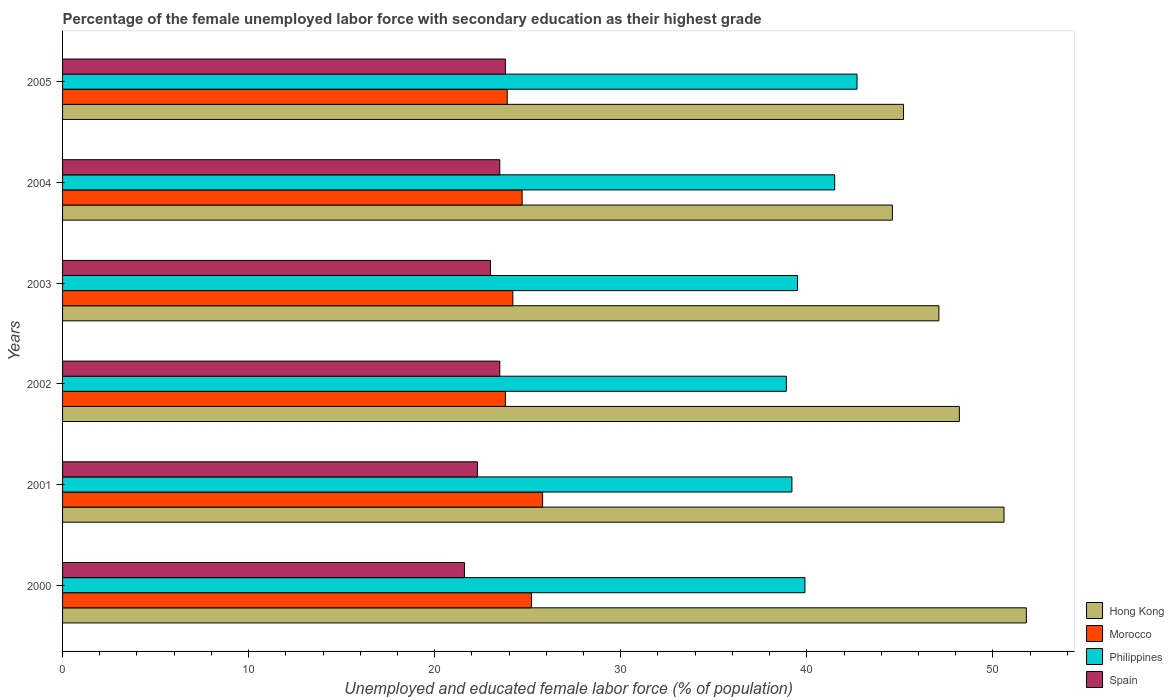How many bars are there on the 5th tick from the top?
Your response must be concise. 4. How many bars are there on the 4th tick from the bottom?
Keep it short and to the point. 4. In how many cases, is the number of bars for a given year not equal to the number of legend labels?
Provide a short and direct response. 0. What is the percentage of the unemployed female labor force with secondary education in Hong Kong in 2000?
Your answer should be compact. 51.8. Across all years, what is the maximum percentage of the unemployed female labor force with secondary education in Hong Kong?
Offer a very short reply. 51.8. Across all years, what is the minimum percentage of the unemployed female labor force with secondary education in Hong Kong?
Provide a short and direct response. 44.6. In which year was the percentage of the unemployed female labor force with secondary education in Spain maximum?
Provide a succinct answer. 2005. What is the total percentage of the unemployed female labor force with secondary education in Spain in the graph?
Offer a terse response. 137.7. What is the difference between the percentage of the unemployed female labor force with secondary education in Hong Kong in 2003 and that in 2005?
Offer a very short reply. 1.9. What is the difference between the percentage of the unemployed female labor force with secondary education in Philippines in 2000 and the percentage of the unemployed female labor force with secondary education in Morocco in 2003?
Make the answer very short. 15.7. What is the average percentage of the unemployed female labor force with secondary education in Morocco per year?
Ensure brevity in your answer.  24.6. In the year 2000, what is the difference between the percentage of the unemployed female labor force with secondary education in Morocco and percentage of the unemployed female labor force with secondary education in Hong Kong?
Your answer should be very brief. -26.6. In how many years, is the percentage of the unemployed female labor force with secondary education in Philippines greater than 20 %?
Your response must be concise. 6. What is the ratio of the percentage of the unemployed female labor force with secondary education in Hong Kong in 2003 to that in 2005?
Your answer should be very brief. 1.04. Is the percentage of the unemployed female labor force with secondary education in Morocco in 2001 less than that in 2005?
Make the answer very short. No. Is the difference between the percentage of the unemployed female labor force with secondary education in Morocco in 2004 and 2005 greater than the difference between the percentage of the unemployed female labor force with secondary education in Hong Kong in 2004 and 2005?
Offer a very short reply. Yes. What is the difference between the highest and the second highest percentage of the unemployed female labor force with secondary education in Philippines?
Your response must be concise. 1.2. What is the difference between the highest and the lowest percentage of the unemployed female labor force with secondary education in Spain?
Your answer should be compact. 2.2. In how many years, is the percentage of the unemployed female labor force with secondary education in Hong Kong greater than the average percentage of the unemployed female labor force with secondary education in Hong Kong taken over all years?
Keep it short and to the point. 3. Is the sum of the percentage of the unemployed female labor force with secondary education in Hong Kong in 2002 and 2004 greater than the maximum percentage of the unemployed female labor force with secondary education in Philippines across all years?
Your answer should be compact. Yes. What does the 3rd bar from the bottom in 2003 represents?
Keep it short and to the point. Philippines. Is it the case that in every year, the sum of the percentage of the unemployed female labor force with secondary education in Morocco and percentage of the unemployed female labor force with secondary education in Philippines is greater than the percentage of the unemployed female labor force with secondary education in Hong Kong?
Provide a succinct answer. Yes. How many bars are there?
Provide a short and direct response. 24. What is the difference between two consecutive major ticks on the X-axis?
Make the answer very short. 10. Does the graph contain grids?
Provide a succinct answer. No. What is the title of the graph?
Provide a succinct answer. Percentage of the female unemployed labor force with secondary education as their highest grade. Does "Iceland" appear as one of the legend labels in the graph?
Your response must be concise. No. What is the label or title of the X-axis?
Keep it short and to the point. Unemployed and educated female labor force (% of population). What is the Unemployed and educated female labor force (% of population) in Hong Kong in 2000?
Make the answer very short. 51.8. What is the Unemployed and educated female labor force (% of population) of Morocco in 2000?
Your answer should be very brief. 25.2. What is the Unemployed and educated female labor force (% of population) of Philippines in 2000?
Keep it short and to the point. 39.9. What is the Unemployed and educated female labor force (% of population) of Spain in 2000?
Offer a terse response. 21.6. What is the Unemployed and educated female labor force (% of population) in Hong Kong in 2001?
Make the answer very short. 50.6. What is the Unemployed and educated female labor force (% of population) of Morocco in 2001?
Your answer should be compact. 25.8. What is the Unemployed and educated female labor force (% of population) in Philippines in 2001?
Give a very brief answer. 39.2. What is the Unemployed and educated female labor force (% of population) of Spain in 2001?
Your answer should be compact. 22.3. What is the Unemployed and educated female labor force (% of population) of Hong Kong in 2002?
Provide a succinct answer. 48.2. What is the Unemployed and educated female labor force (% of population) in Morocco in 2002?
Make the answer very short. 23.8. What is the Unemployed and educated female labor force (% of population) in Philippines in 2002?
Ensure brevity in your answer.  38.9. What is the Unemployed and educated female labor force (% of population) of Hong Kong in 2003?
Ensure brevity in your answer.  47.1. What is the Unemployed and educated female labor force (% of population) in Morocco in 2003?
Ensure brevity in your answer.  24.2. What is the Unemployed and educated female labor force (% of population) in Philippines in 2003?
Keep it short and to the point. 39.5. What is the Unemployed and educated female labor force (% of population) in Hong Kong in 2004?
Provide a short and direct response. 44.6. What is the Unemployed and educated female labor force (% of population) in Morocco in 2004?
Provide a succinct answer. 24.7. What is the Unemployed and educated female labor force (% of population) of Philippines in 2004?
Keep it short and to the point. 41.5. What is the Unemployed and educated female labor force (% of population) of Hong Kong in 2005?
Give a very brief answer. 45.2. What is the Unemployed and educated female labor force (% of population) in Morocco in 2005?
Give a very brief answer. 23.9. What is the Unemployed and educated female labor force (% of population) of Philippines in 2005?
Make the answer very short. 42.7. What is the Unemployed and educated female labor force (% of population) of Spain in 2005?
Make the answer very short. 23.8. Across all years, what is the maximum Unemployed and educated female labor force (% of population) of Hong Kong?
Your response must be concise. 51.8. Across all years, what is the maximum Unemployed and educated female labor force (% of population) of Morocco?
Keep it short and to the point. 25.8. Across all years, what is the maximum Unemployed and educated female labor force (% of population) in Philippines?
Offer a very short reply. 42.7. Across all years, what is the maximum Unemployed and educated female labor force (% of population) of Spain?
Offer a very short reply. 23.8. Across all years, what is the minimum Unemployed and educated female labor force (% of population) of Hong Kong?
Make the answer very short. 44.6. Across all years, what is the minimum Unemployed and educated female labor force (% of population) of Morocco?
Provide a succinct answer. 23.8. Across all years, what is the minimum Unemployed and educated female labor force (% of population) of Philippines?
Provide a succinct answer. 38.9. Across all years, what is the minimum Unemployed and educated female labor force (% of population) in Spain?
Provide a short and direct response. 21.6. What is the total Unemployed and educated female labor force (% of population) in Hong Kong in the graph?
Your response must be concise. 287.5. What is the total Unemployed and educated female labor force (% of population) of Morocco in the graph?
Make the answer very short. 147.6. What is the total Unemployed and educated female labor force (% of population) of Philippines in the graph?
Provide a short and direct response. 241.7. What is the total Unemployed and educated female labor force (% of population) in Spain in the graph?
Keep it short and to the point. 137.7. What is the difference between the Unemployed and educated female labor force (% of population) in Hong Kong in 2000 and that in 2001?
Ensure brevity in your answer.  1.2. What is the difference between the Unemployed and educated female labor force (% of population) of Philippines in 2000 and that in 2001?
Give a very brief answer. 0.7. What is the difference between the Unemployed and educated female labor force (% of population) in Spain in 2000 and that in 2001?
Your response must be concise. -0.7. What is the difference between the Unemployed and educated female labor force (% of population) in Hong Kong in 2000 and that in 2002?
Your answer should be compact. 3.6. What is the difference between the Unemployed and educated female labor force (% of population) in Morocco in 2000 and that in 2002?
Make the answer very short. 1.4. What is the difference between the Unemployed and educated female labor force (% of population) in Philippines in 2000 and that in 2002?
Offer a very short reply. 1. What is the difference between the Unemployed and educated female labor force (% of population) in Morocco in 2000 and that in 2003?
Make the answer very short. 1. What is the difference between the Unemployed and educated female labor force (% of population) in Philippines in 2000 and that in 2003?
Keep it short and to the point. 0.4. What is the difference between the Unemployed and educated female labor force (% of population) of Spain in 2000 and that in 2003?
Your answer should be very brief. -1.4. What is the difference between the Unemployed and educated female labor force (% of population) of Spain in 2000 and that in 2004?
Your response must be concise. -1.9. What is the difference between the Unemployed and educated female labor force (% of population) in Spain in 2001 and that in 2002?
Keep it short and to the point. -1.2. What is the difference between the Unemployed and educated female labor force (% of population) of Hong Kong in 2001 and that in 2003?
Make the answer very short. 3.5. What is the difference between the Unemployed and educated female labor force (% of population) in Morocco in 2001 and that in 2003?
Make the answer very short. 1.6. What is the difference between the Unemployed and educated female labor force (% of population) in Spain in 2001 and that in 2003?
Make the answer very short. -0.7. What is the difference between the Unemployed and educated female labor force (% of population) in Hong Kong in 2001 and that in 2004?
Your answer should be compact. 6. What is the difference between the Unemployed and educated female labor force (% of population) of Morocco in 2001 and that in 2004?
Provide a short and direct response. 1.1. What is the difference between the Unemployed and educated female labor force (% of population) of Spain in 2001 and that in 2004?
Your answer should be compact. -1.2. What is the difference between the Unemployed and educated female labor force (% of population) in Hong Kong in 2001 and that in 2005?
Make the answer very short. 5.4. What is the difference between the Unemployed and educated female labor force (% of population) of Morocco in 2001 and that in 2005?
Ensure brevity in your answer.  1.9. What is the difference between the Unemployed and educated female labor force (% of population) in Philippines in 2001 and that in 2005?
Provide a short and direct response. -3.5. What is the difference between the Unemployed and educated female labor force (% of population) of Spain in 2001 and that in 2005?
Offer a very short reply. -1.5. What is the difference between the Unemployed and educated female labor force (% of population) in Morocco in 2002 and that in 2004?
Your response must be concise. -0.9. What is the difference between the Unemployed and educated female labor force (% of population) in Spain in 2002 and that in 2004?
Your response must be concise. 0. What is the difference between the Unemployed and educated female labor force (% of population) of Spain in 2002 and that in 2005?
Offer a terse response. -0.3. What is the difference between the Unemployed and educated female labor force (% of population) of Hong Kong in 2003 and that in 2004?
Give a very brief answer. 2.5. What is the difference between the Unemployed and educated female labor force (% of population) of Morocco in 2003 and that in 2004?
Offer a very short reply. -0.5. What is the difference between the Unemployed and educated female labor force (% of population) in Spain in 2003 and that in 2004?
Offer a very short reply. -0.5. What is the difference between the Unemployed and educated female labor force (% of population) in Hong Kong in 2003 and that in 2005?
Provide a short and direct response. 1.9. What is the difference between the Unemployed and educated female labor force (% of population) of Morocco in 2003 and that in 2005?
Make the answer very short. 0.3. What is the difference between the Unemployed and educated female labor force (% of population) in Philippines in 2003 and that in 2005?
Your answer should be compact. -3.2. What is the difference between the Unemployed and educated female labor force (% of population) of Morocco in 2004 and that in 2005?
Ensure brevity in your answer.  0.8. What is the difference between the Unemployed and educated female labor force (% of population) in Philippines in 2004 and that in 2005?
Ensure brevity in your answer.  -1.2. What is the difference between the Unemployed and educated female labor force (% of population) of Spain in 2004 and that in 2005?
Provide a succinct answer. -0.3. What is the difference between the Unemployed and educated female labor force (% of population) of Hong Kong in 2000 and the Unemployed and educated female labor force (% of population) of Philippines in 2001?
Give a very brief answer. 12.6. What is the difference between the Unemployed and educated female labor force (% of population) of Hong Kong in 2000 and the Unemployed and educated female labor force (% of population) of Spain in 2001?
Keep it short and to the point. 29.5. What is the difference between the Unemployed and educated female labor force (% of population) in Morocco in 2000 and the Unemployed and educated female labor force (% of population) in Spain in 2001?
Keep it short and to the point. 2.9. What is the difference between the Unemployed and educated female labor force (% of population) of Philippines in 2000 and the Unemployed and educated female labor force (% of population) of Spain in 2001?
Provide a short and direct response. 17.6. What is the difference between the Unemployed and educated female labor force (% of population) in Hong Kong in 2000 and the Unemployed and educated female labor force (% of population) in Morocco in 2002?
Keep it short and to the point. 28. What is the difference between the Unemployed and educated female labor force (% of population) of Hong Kong in 2000 and the Unemployed and educated female labor force (% of population) of Philippines in 2002?
Your answer should be compact. 12.9. What is the difference between the Unemployed and educated female labor force (% of population) in Hong Kong in 2000 and the Unemployed and educated female labor force (% of population) in Spain in 2002?
Give a very brief answer. 28.3. What is the difference between the Unemployed and educated female labor force (% of population) in Morocco in 2000 and the Unemployed and educated female labor force (% of population) in Philippines in 2002?
Your answer should be very brief. -13.7. What is the difference between the Unemployed and educated female labor force (% of population) in Hong Kong in 2000 and the Unemployed and educated female labor force (% of population) in Morocco in 2003?
Your answer should be very brief. 27.6. What is the difference between the Unemployed and educated female labor force (% of population) of Hong Kong in 2000 and the Unemployed and educated female labor force (% of population) of Philippines in 2003?
Give a very brief answer. 12.3. What is the difference between the Unemployed and educated female labor force (% of population) in Hong Kong in 2000 and the Unemployed and educated female labor force (% of population) in Spain in 2003?
Ensure brevity in your answer.  28.8. What is the difference between the Unemployed and educated female labor force (% of population) in Morocco in 2000 and the Unemployed and educated female labor force (% of population) in Philippines in 2003?
Your answer should be compact. -14.3. What is the difference between the Unemployed and educated female labor force (% of population) in Philippines in 2000 and the Unemployed and educated female labor force (% of population) in Spain in 2003?
Your answer should be compact. 16.9. What is the difference between the Unemployed and educated female labor force (% of population) of Hong Kong in 2000 and the Unemployed and educated female labor force (% of population) of Morocco in 2004?
Provide a short and direct response. 27.1. What is the difference between the Unemployed and educated female labor force (% of population) of Hong Kong in 2000 and the Unemployed and educated female labor force (% of population) of Philippines in 2004?
Provide a succinct answer. 10.3. What is the difference between the Unemployed and educated female labor force (% of population) in Hong Kong in 2000 and the Unemployed and educated female labor force (% of population) in Spain in 2004?
Keep it short and to the point. 28.3. What is the difference between the Unemployed and educated female labor force (% of population) in Morocco in 2000 and the Unemployed and educated female labor force (% of population) in Philippines in 2004?
Provide a succinct answer. -16.3. What is the difference between the Unemployed and educated female labor force (% of population) of Morocco in 2000 and the Unemployed and educated female labor force (% of population) of Spain in 2004?
Provide a short and direct response. 1.7. What is the difference between the Unemployed and educated female labor force (% of population) in Philippines in 2000 and the Unemployed and educated female labor force (% of population) in Spain in 2004?
Your answer should be very brief. 16.4. What is the difference between the Unemployed and educated female labor force (% of population) of Hong Kong in 2000 and the Unemployed and educated female labor force (% of population) of Morocco in 2005?
Your response must be concise. 27.9. What is the difference between the Unemployed and educated female labor force (% of population) in Hong Kong in 2000 and the Unemployed and educated female labor force (% of population) in Philippines in 2005?
Offer a very short reply. 9.1. What is the difference between the Unemployed and educated female labor force (% of population) of Morocco in 2000 and the Unemployed and educated female labor force (% of population) of Philippines in 2005?
Provide a succinct answer. -17.5. What is the difference between the Unemployed and educated female labor force (% of population) in Morocco in 2000 and the Unemployed and educated female labor force (% of population) in Spain in 2005?
Your response must be concise. 1.4. What is the difference between the Unemployed and educated female labor force (% of population) in Philippines in 2000 and the Unemployed and educated female labor force (% of population) in Spain in 2005?
Offer a very short reply. 16.1. What is the difference between the Unemployed and educated female labor force (% of population) of Hong Kong in 2001 and the Unemployed and educated female labor force (% of population) of Morocco in 2002?
Your answer should be very brief. 26.8. What is the difference between the Unemployed and educated female labor force (% of population) of Hong Kong in 2001 and the Unemployed and educated female labor force (% of population) of Spain in 2002?
Provide a short and direct response. 27.1. What is the difference between the Unemployed and educated female labor force (% of population) in Morocco in 2001 and the Unemployed and educated female labor force (% of population) in Philippines in 2002?
Provide a short and direct response. -13.1. What is the difference between the Unemployed and educated female labor force (% of population) of Morocco in 2001 and the Unemployed and educated female labor force (% of population) of Spain in 2002?
Your answer should be very brief. 2.3. What is the difference between the Unemployed and educated female labor force (% of population) in Philippines in 2001 and the Unemployed and educated female labor force (% of population) in Spain in 2002?
Provide a succinct answer. 15.7. What is the difference between the Unemployed and educated female labor force (% of population) in Hong Kong in 2001 and the Unemployed and educated female labor force (% of population) in Morocco in 2003?
Offer a very short reply. 26.4. What is the difference between the Unemployed and educated female labor force (% of population) of Hong Kong in 2001 and the Unemployed and educated female labor force (% of population) of Philippines in 2003?
Give a very brief answer. 11.1. What is the difference between the Unemployed and educated female labor force (% of population) in Hong Kong in 2001 and the Unemployed and educated female labor force (% of population) in Spain in 2003?
Your response must be concise. 27.6. What is the difference between the Unemployed and educated female labor force (% of population) of Morocco in 2001 and the Unemployed and educated female labor force (% of population) of Philippines in 2003?
Ensure brevity in your answer.  -13.7. What is the difference between the Unemployed and educated female labor force (% of population) of Morocco in 2001 and the Unemployed and educated female labor force (% of population) of Spain in 2003?
Your response must be concise. 2.8. What is the difference between the Unemployed and educated female labor force (% of population) of Philippines in 2001 and the Unemployed and educated female labor force (% of population) of Spain in 2003?
Give a very brief answer. 16.2. What is the difference between the Unemployed and educated female labor force (% of population) of Hong Kong in 2001 and the Unemployed and educated female labor force (% of population) of Morocco in 2004?
Make the answer very short. 25.9. What is the difference between the Unemployed and educated female labor force (% of population) of Hong Kong in 2001 and the Unemployed and educated female labor force (% of population) of Philippines in 2004?
Your answer should be compact. 9.1. What is the difference between the Unemployed and educated female labor force (% of population) in Hong Kong in 2001 and the Unemployed and educated female labor force (% of population) in Spain in 2004?
Make the answer very short. 27.1. What is the difference between the Unemployed and educated female labor force (% of population) in Morocco in 2001 and the Unemployed and educated female labor force (% of population) in Philippines in 2004?
Ensure brevity in your answer.  -15.7. What is the difference between the Unemployed and educated female labor force (% of population) of Morocco in 2001 and the Unemployed and educated female labor force (% of population) of Spain in 2004?
Make the answer very short. 2.3. What is the difference between the Unemployed and educated female labor force (% of population) of Hong Kong in 2001 and the Unemployed and educated female labor force (% of population) of Morocco in 2005?
Offer a terse response. 26.7. What is the difference between the Unemployed and educated female labor force (% of population) of Hong Kong in 2001 and the Unemployed and educated female labor force (% of population) of Spain in 2005?
Your response must be concise. 26.8. What is the difference between the Unemployed and educated female labor force (% of population) in Morocco in 2001 and the Unemployed and educated female labor force (% of population) in Philippines in 2005?
Your response must be concise. -16.9. What is the difference between the Unemployed and educated female labor force (% of population) of Morocco in 2001 and the Unemployed and educated female labor force (% of population) of Spain in 2005?
Provide a succinct answer. 2. What is the difference between the Unemployed and educated female labor force (% of population) of Philippines in 2001 and the Unemployed and educated female labor force (% of population) of Spain in 2005?
Keep it short and to the point. 15.4. What is the difference between the Unemployed and educated female labor force (% of population) of Hong Kong in 2002 and the Unemployed and educated female labor force (% of population) of Morocco in 2003?
Give a very brief answer. 24. What is the difference between the Unemployed and educated female labor force (% of population) in Hong Kong in 2002 and the Unemployed and educated female labor force (% of population) in Spain in 2003?
Your response must be concise. 25.2. What is the difference between the Unemployed and educated female labor force (% of population) of Morocco in 2002 and the Unemployed and educated female labor force (% of population) of Philippines in 2003?
Keep it short and to the point. -15.7. What is the difference between the Unemployed and educated female labor force (% of population) of Philippines in 2002 and the Unemployed and educated female labor force (% of population) of Spain in 2003?
Ensure brevity in your answer.  15.9. What is the difference between the Unemployed and educated female labor force (% of population) in Hong Kong in 2002 and the Unemployed and educated female labor force (% of population) in Morocco in 2004?
Offer a very short reply. 23.5. What is the difference between the Unemployed and educated female labor force (% of population) of Hong Kong in 2002 and the Unemployed and educated female labor force (% of population) of Philippines in 2004?
Provide a succinct answer. 6.7. What is the difference between the Unemployed and educated female labor force (% of population) in Hong Kong in 2002 and the Unemployed and educated female labor force (% of population) in Spain in 2004?
Your answer should be compact. 24.7. What is the difference between the Unemployed and educated female labor force (% of population) of Morocco in 2002 and the Unemployed and educated female labor force (% of population) of Philippines in 2004?
Provide a short and direct response. -17.7. What is the difference between the Unemployed and educated female labor force (% of population) of Morocco in 2002 and the Unemployed and educated female labor force (% of population) of Spain in 2004?
Your answer should be very brief. 0.3. What is the difference between the Unemployed and educated female labor force (% of population) of Hong Kong in 2002 and the Unemployed and educated female labor force (% of population) of Morocco in 2005?
Provide a short and direct response. 24.3. What is the difference between the Unemployed and educated female labor force (% of population) of Hong Kong in 2002 and the Unemployed and educated female labor force (% of population) of Spain in 2005?
Your response must be concise. 24.4. What is the difference between the Unemployed and educated female labor force (% of population) of Morocco in 2002 and the Unemployed and educated female labor force (% of population) of Philippines in 2005?
Offer a terse response. -18.9. What is the difference between the Unemployed and educated female labor force (% of population) of Hong Kong in 2003 and the Unemployed and educated female labor force (% of population) of Morocco in 2004?
Make the answer very short. 22.4. What is the difference between the Unemployed and educated female labor force (% of population) of Hong Kong in 2003 and the Unemployed and educated female labor force (% of population) of Spain in 2004?
Give a very brief answer. 23.6. What is the difference between the Unemployed and educated female labor force (% of population) in Morocco in 2003 and the Unemployed and educated female labor force (% of population) in Philippines in 2004?
Keep it short and to the point. -17.3. What is the difference between the Unemployed and educated female labor force (% of population) in Morocco in 2003 and the Unemployed and educated female labor force (% of population) in Spain in 2004?
Ensure brevity in your answer.  0.7. What is the difference between the Unemployed and educated female labor force (% of population) of Hong Kong in 2003 and the Unemployed and educated female labor force (% of population) of Morocco in 2005?
Ensure brevity in your answer.  23.2. What is the difference between the Unemployed and educated female labor force (% of population) in Hong Kong in 2003 and the Unemployed and educated female labor force (% of population) in Philippines in 2005?
Offer a terse response. 4.4. What is the difference between the Unemployed and educated female labor force (% of population) of Hong Kong in 2003 and the Unemployed and educated female labor force (% of population) of Spain in 2005?
Your answer should be very brief. 23.3. What is the difference between the Unemployed and educated female labor force (% of population) of Morocco in 2003 and the Unemployed and educated female labor force (% of population) of Philippines in 2005?
Your answer should be compact. -18.5. What is the difference between the Unemployed and educated female labor force (% of population) of Hong Kong in 2004 and the Unemployed and educated female labor force (% of population) of Morocco in 2005?
Provide a succinct answer. 20.7. What is the difference between the Unemployed and educated female labor force (% of population) of Hong Kong in 2004 and the Unemployed and educated female labor force (% of population) of Spain in 2005?
Offer a terse response. 20.8. What is the difference between the Unemployed and educated female labor force (% of population) of Morocco in 2004 and the Unemployed and educated female labor force (% of population) of Philippines in 2005?
Ensure brevity in your answer.  -18. What is the average Unemployed and educated female labor force (% of population) of Hong Kong per year?
Your answer should be compact. 47.92. What is the average Unemployed and educated female labor force (% of population) of Morocco per year?
Offer a very short reply. 24.6. What is the average Unemployed and educated female labor force (% of population) in Philippines per year?
Keep it short and to the point. 40.28. What is the average Unemployed and educated female labor force (% of population) of Spain per year?
Keep it short and to the point. 22.95. In the year 2000, what is the difference between the Unemployed and educated female labor force (% of population) in Hong Kong and Unemployed and educated female labor force (% of population) in Morocco?
Ensure brevity in your answer.  26.6. In the year 2000, what is the difference between the Unemployed and educated female labor force (% of population) in Hong Kong and Unemployed and educated female labor force (% of population) in Philippines?
Provide a succinct answer. 11.9. In the year 2000, what is the difference between the Unemployed and educated female labor force (% of population) of Hong Kong and Unemployed and educated female labor force (% of population) of Spain?
Keep it short and to the point. 30.2. In the year 2000, what is the difference between the Unemployed and educated female labor force (% of population) of Morocco and Unemployed and educated female labor force (% of population) of Philippines?
Keep it short and to the point. -14.7. In the year 2000, what is the difference between the Unemployed and educated female labor force (% of population) of Morocco and Unemployed and educated female labor force (% of population) of Spain?
Give a very brief answer. 3.6. In the year 2000, what is the difference between the Unemployed and educated female labor force (% of population) in Philippines and Unemployed and educated female labor force (% of population) in Spain?
Your answer should be very brief. 18.3. In the year 2001, what is the difference between the Unemployed and educated female labor force (% of population) in Hong Kong and Unemployed and educated female labor force (% of population) in Morocco?
Make the answer very short. 24.8. In the year 2001, what is the difference between the Unemployed and educated female labor force (% of population) in Hong Kong and Unemployed and educated female labor force (% of population) in Philippines?
Your answer should be very brief. 11.4. In the year 2001, what is the difference between the Unemployed and educated female labor force (% of population) in Hong Kong and Unemployed and educated female labor force (% of population) in Spain?
Keep it short and to the point. 28.3. In the year 2001, what is the difference between the Unemployed and educated female labor force (% of population) in Morocco and Unemployed and educated female labor force (% of population) in Spain?
Make the answer very short. 3.5. In the year 2001, what is the difference between the Unemployed and educated female labor force (% of population) in Philippines and Unemployed and educated female labor force (% of population) in Spain?
Give a very brief answer. 16.9. In the year 2002, what is the difference between the Unemployed and educated female labor force (% of population) of Hong Kong and Unemployed and educated female labor force (% of population) of Morocco?
Provide a succinct answer. 24.4. In the year 2002, what is the difference between the Unemployed and educated female labor force (% of population) in Hong Kong and Unemployed and educated female labor force (% of population) in Philippines?
Ensure brevity in your answer.  9.3. In the year 2002, what is the difference between the Unemployed and educated female labor force (% of population) of Hong Kong and Unemployed and educated female labor force (% of population) of Spain?
Ensure brevity in your answer.  24.7. In the year 2002, what is the difference between the Unemployed and educated female labor force (% of population) in Morocco and Unemployed and educated female labor force (% of population) in Philippines?
Your answer should be compact. -15.1. In the year 2003, what is the difference between the Unemployed and educated female labor force (% of population) of Hong Kong and Unemployed and educated female labor force (% of population) of Morocco?
Your response must be concise. 22.9. In the year 2003, what is the difference between the Unemployed and educated female labor force (% of population) in Hong Kong and Unemployed and educated female labor force (% of population) in Philippines?
Ensure brevity in your answer.  7.6. In the year 2003, what is the difference between the Unemployed and educated female labor force (% of population) in Hong Kong and Unemployed and educated female labor force (% of population) in Spain?
Ensure brevity in your answer.  24.1. In the year 2003, what is the difference between the Unemployed and educated female labor force (% of population) in Morocco and Unemployed and educated female labor force (% of population) in Philippines?
Your answer should be compact. -15.3. In the year 2003, what is the difference between the Unemployed and educated female labor force (% of population) in Morocco and Unemployed and educated female labor force (% of population) in Spain?
Offer a terse response. 1.2. In the year 2003, what is the difference between the Unemployed and educated female labor force (% of population) in Philippines and Unemployed and educated female labor force (% of population) in Spain?
Your answer should be very brief. 16.5. In the year 2004, what is the difference between the Unemployed and educated female labor force (% of population) of Hong Kong and Unemployed and educated female labor force (% of population) of Philippines?
Your answer should be very brief. 3.1. In the year 2004, what is the difference between the Unemployed and educated female labor force (% of population) of Hong Kong and Unemployed and educated female labor force (% of population) of Spain?
Give a very brief answer. 21.1. In the year 2004, what is the difference between the Unemployed and educated female labor force (% of population) of Morocco and Unemployed and educated female labor force (% of population) of Philippines?
Your answer should be compact. -16.8. In the year 2004, what is the difference between the Unemployed and educated female labor force (% of population) of Morocco and Unemployed and educated female labor force (% of population) of Spain?
Your answer should be compact. 1.2. In the year 2004, what is the difference between the Unemployed and educated female labor force (% of population) of Philippines and Unemployed and educated female labor force (% of population) of Spain?
Give a very brief answer. 18. In the year 2005, what is the difference between the Unemployed and educated female labor force (% of population) of Hong Kong and Unemployed and educated female labor force (% of population) of Morocco?
Keep it short and to the point. 21.3. In the year 2005, what is the difference between the Unemployed and educated female labor force (% of population) of Hong Kong and Unemployed and educated female labor force (% of population) of Spain?
Make the answer very short. 21.4. In the year 2005, what is the difference between the Unemployed and educated female labor force (% of population) in Morocco and Unemployed and educated female labor force (% of population) in Philippines?
Ensure brevity in your answer.  -18.8. In the year 2005, what is the difference between the Unemployed and educated female labor force (% of population) of Morocco and Unemployed and educated female labor force (% of population) of Spain?
Offer a terse response. 0.1. What is the ratio of the Unemployed and educated female labor force (% of population) in Hong Kong in 2000 to that in 2001?
Offer a very short reply. 1.02. What is the ratio of the Unemployed and educated female labor force (% of population) of Morocco in 2000 to that in 2001?
Your response must be concise. 0.98. What is the ratio of the Unemployed and educated female labor force (% of population) of Philippines in 2000 to that in 2001?
Your response must be concise. 1.02. What is the ratio of the Unemployed and educated female labor force (% of population) of Spain in 2000 to that in 2001?
Keep it short and to the point. 0.97. What is the ratio of the Unemployed and educated female labor force (% of population) of Hong Kong in 2000 to that in 2002?
Give a very brief answer. 1.07. What is the ratio of the Unemployed and educated female labor force (% of population) of Morocco in 2000 to that in 2002?
Offer a terse response. 1.06. What is the ratio of the Unemployed and educated female labor force (% of population) of Philippines in 2000 to that in 2002?
Your response must be concise. 1.03. What is the ratio of the Unemployed and educated female labor force (% of population) in Spain in 2000 to that in 2002?
Your answer should be compact. 0.92. What is the ratio of the Unemployed and educated female labor force (% of population) in Hong Kong in 2000 to that in 2003?
Your answer should be compact. 1.1. What is the ratio of the Unemployed and educated female labor force (% of population) of Morocco in 2000 to that in 2003?
Offer a very short reply. 1.04. What is the ratio of the Unemployed and educated female labor force (% of population) of Philippines in 2000 to that in 2003?
Provide a short and direct response. 1.01. What is the ratio of the Unemployed and educated female labor force (% of population) in Spain in 2000 to that in 2003?
Give a very brief answer. 0.94. What is the ratio of the Unemployed and educated female labor force (% of population) of Hong Kong in 2000 to that in 2004?
Provide a succinct answer. 1.16. What is the ratio of the Unemployed and educated female labor force (% of population) in Morocco in 2000 to that in 2004?
Provide a succinct answer. 1.02. What is the ratio of the Unemployed and educated female labor force (% of population) in Philippines in 2000 to that in 2004?
Offer a terse response. 0.96. What is the ratio of the Unemployed and educated female labor force (% of population) in Spain in 2000 to that in 2004?
Offer a terse response. 0.92. What is the ratio of the Unemployed and educated female labor force (% of population) in Hong Kong in 2000 to that in 2005?
Provide a succinct answer. 1.15. What is the ratio of the Unemployed and educated female labor force (% of population) in Morocco in 2000 to that in 2005?
Your answer should be compact. 1.05. What is the ratio of the Unemployed and educated female labor force (% of population) in Philippines in 2000 to that in 2005?
Ensure brevity in your answer.  0.93. What is the ratio of the Unemployed and educated female labor force (% of population) in Spain in 2000 to that in 2005?
Your response must be concise. 0.91. What is the ratio of the Unemployed and educated female labor force (% of population) of Hong Kong in 2001 to that in 2002?
Give a very brief answer. 1.05. What is the ratio of the Unemployed and educated female labor force (% of population) in Morocco in 2001 to that in 2002?
Give a very brief answer. 1.08. What is the ratio of the Unemployed and educated female labor force (% of population) in Philippines in 2001 to that in 2002?
Your answer should be very brief. 1.01. What is the ratio of the Unemployed and educated female labor force (% of population) in Spain in 2001 to that in 2002?
Offer a very short reply. 0.95. What is the ratio of the Unemployed and educated female labor force (% of population) in Hong Kong in 2001 to that in 2003?
Offer a very short reply. 1.07. What is the ratio of the Unemployed and educated female labor force (% of population) in Morocco in 2001 to that in 2003?
Give a very brief answer. 1.07. What is the ratio of the Unemployed and educated female labor force (% of population) of Spain in 2001 to that in 2003?
Give a very brief answer. 0.97. What is the ratio of the Unemployed and educated female labor force (% of population) in Hong Kong in 2001 to that in 2004?
Offer a very short reply. 1.13. What is the ratio of the Unemployed and educated female labor force (% of population) in Morocco in 2001 to that in 2004?
Provide a succinct answer. 1.04. What is the ratio of the Unemployed and educated female labor force (% of population) in Philippines in 2001 to that in 2004?
Provide a succinct answer. 0.94. What is the ratio of the Unemployed and educated female labor force (% of population) of Spain in 2001 to that in 2004?
Make the answer very short. 0.95. What is the ratio of the Unemployed and educated female labor force (% of population) in Hong Kong in 2001 to that in 2005?
Provide a short and direct response. 1.12. What is the ratio of the Unemployed and educated female labor force (% of population) in Morocco in 2001 to that in 2005?
Offer a terse response. 1.08. What is the ratio of the Unemployed and educated female labor force (% of population) in Philippines in 2001 to that in 2005?
Your answer should be very brief. 0.92. What is the ratio of the Unemployed and educated female labor force (% of population) of Spain in 2001 to that in 2005?
Make the answer very short. 0.94. What is the ratio of the Unemployed and educated female labor force (% of population) in Hong Kong in 2002 to that in 2003?
Make the answer very short. 1.02. What is the ratio of the Unemployed and educated female labor force (% of population) in Morocco in 2002 to that in 2003?
Give a very brief answer. 0.98. What is the ratio of the Unemployed and educated female labor force (% of population) in Spain in 2002 to that in 2003?
Offer a terse response. 1.02. What is the ratio of the Unemployed and educated female labor force (% of population) in Hong Kong in 2002 to that in 2004?
Give a very brief answer. 1.08. What is the ratio of the Unemployed and educated female labor force (% of population) of Morocco in 2002 to that in 2004?
Provide a succinct answer. 0.96. What is the ratio of the Unemployed and educated female labor force (% of population) in Philippines in 2002 to that in 2004?
Ensure brevity in your answer.  0.94. What is the ratio of the Unemployed and educated female labor force (% of population) in Hong Kong in 2002 to that in 2005?
Your response must be concise. 1.07. What is the ratio of the Unemployed and educated female labor force (% of population) of Morocco in 2002 to that in 2005?
Make the answer very short. 1. What is the ratio of the Unemployed and educated female labor force (% of population) of Philippines in 2002 to that in 2005?
Keep it short and to the point. 0.91. What is the ratio of the Unemployed and educated female labor force (% of population) in Spain in 2002 to that in 2005?
Provide a succinct answer. 0.99. What is the ratio of the Unemployed and educated female labor force (% of population) of Hong Kong in 2003 to that in 2004?
Ensure brevity in your answer.  1.06. What is the ratio of the Unemployed and educated female labor force (% of population) in Morocco in 2003 to that in 2004?
Offer a terse response. 0.98. What is the ratio of the Unemployed and educated female labor force (% of population) in Philippines in 2003 to that in 2004?
Provide a short and direct response. 0.95. What is the ratio of the Unemployed and educated female labor force (% of population) of Spain in 2003 to that in 2004?
Offer a very short reply. 0.98. What is the ratio of the Unemployed and educated female labor force (% of population) in Hong Kong in 2003 to that in 2005?
Offer a very short reply. 1.04. What is the ratio of the Unemployed and educated female labor force (% of population) in Morocco in 2003 to that in 2005?
Provide a succinct answer. 1.01. What is the ratio of the Unemployed and educated female labor force (% of population) of Philippines in 2003 to that in 2005?
Offer a terse response. 0.93. What is the ratio of the Unemployed and educated female labor force (% of population) in Spain in 2003 to that in 2005?
Your response must be concise. 0.97. What is the ratio of the Unemployed and educated female labor force (% of population) in Hong Kong in 2004 to that in 2005?
Give a very brief answer. 0.99. What is the ratio of the Unemployed and educated female labor force (% of population) in Morocco in 2004 to that in 2005?
Your answer should be compact. 1.03. What is the ratio of the Unemployed and educated female labor force (% of population) of Philippines in 2004 to that in 2005?
Make the answer very short. 0.97. What is the ratio of the Unemployed and educated female labor force (% of population) in Spain in 2004 to that in 2005?
Make the answer very short. 0.99. What is the difference between the highest and the second highest Unemployed and educated female labor force (% of population) in Hong Kong?
Ensure brevity in your answer.  1.2. What is the difference between the highest and the second highest Unemployed and educated female labor force (% of population) of Morocco?
Ensure brevity in your answer.  0.6. What is the difference between the highest and the second highest Unemployed and educated female labor force (% of population) of Spain?
Keep it short and to the point. 0.3. What is the difference between the highest and the lowest Unemployed and educated female labor force (% of population) in Spain?
Your response must be concise. 2.2. 